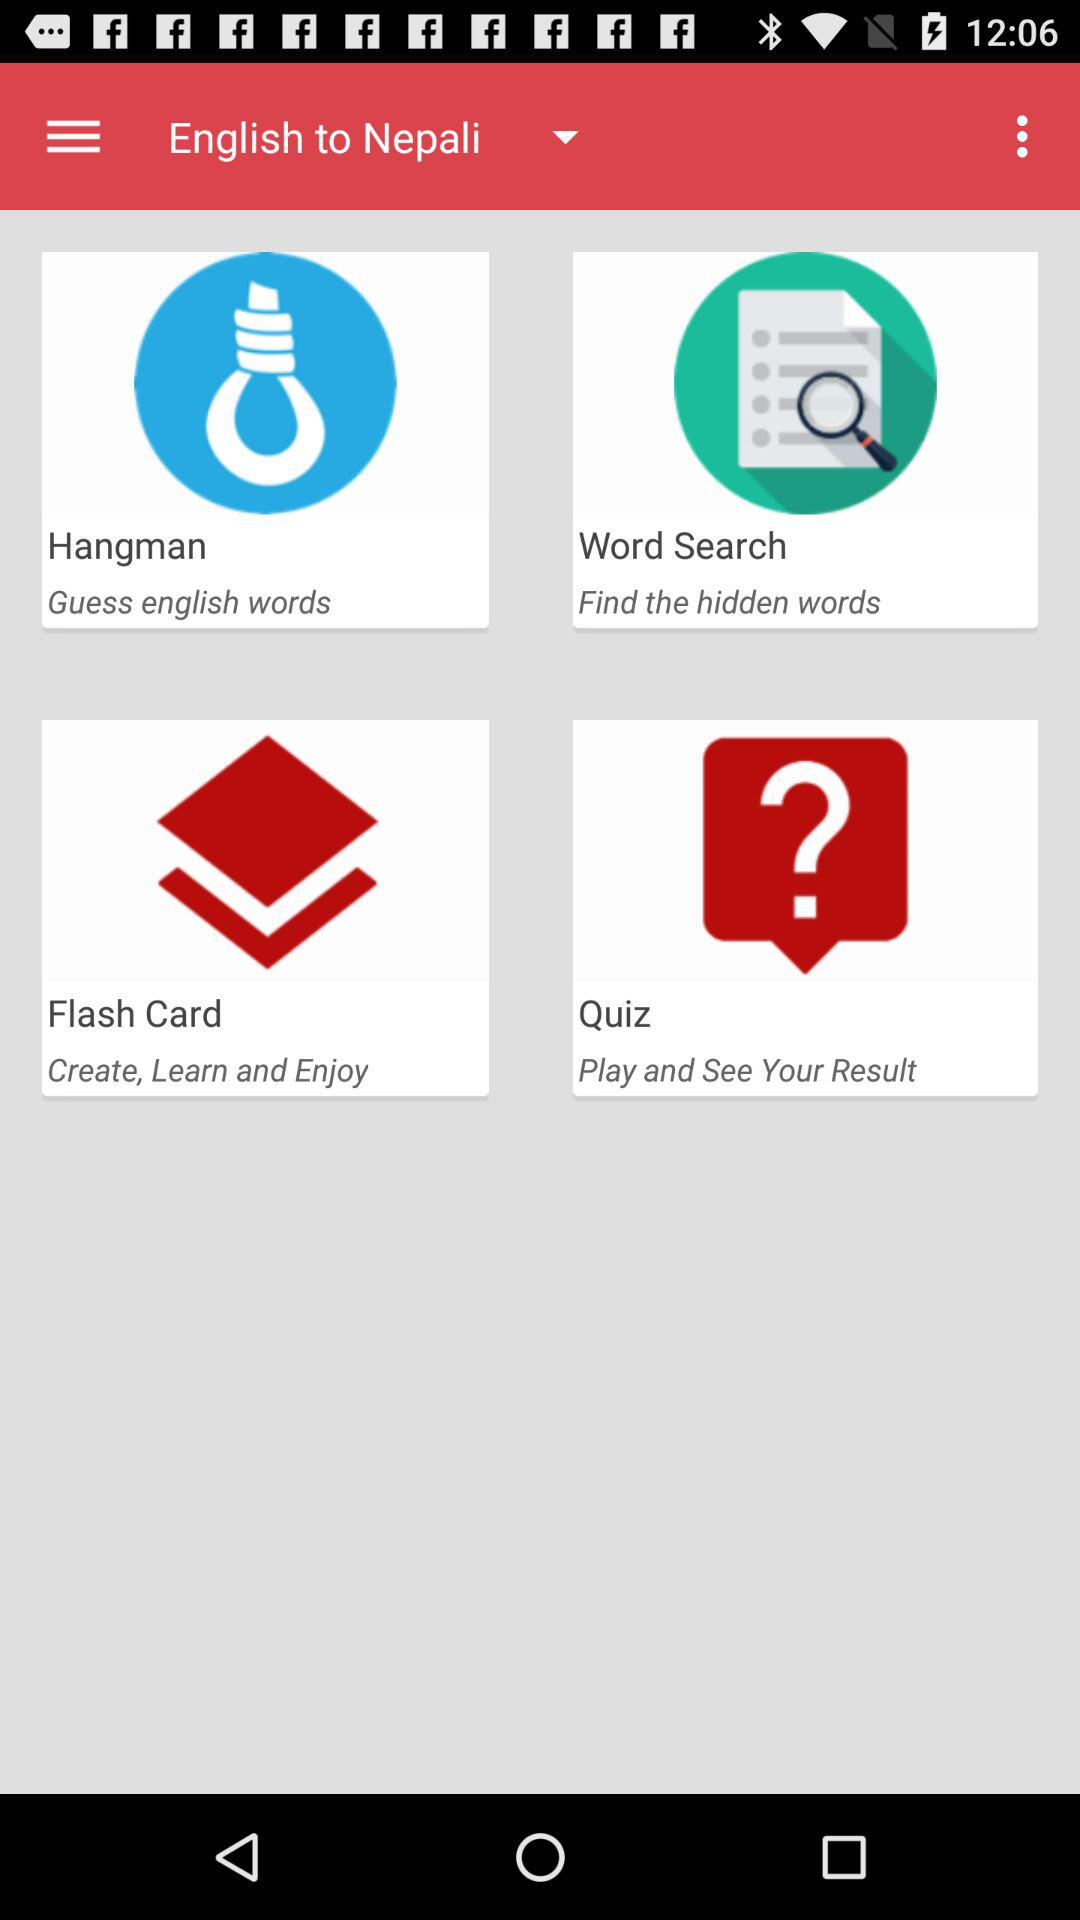Which language translations are available other than English to Nepali?
When the provided information is insufficient, respond with <no answer>. <no answer> 